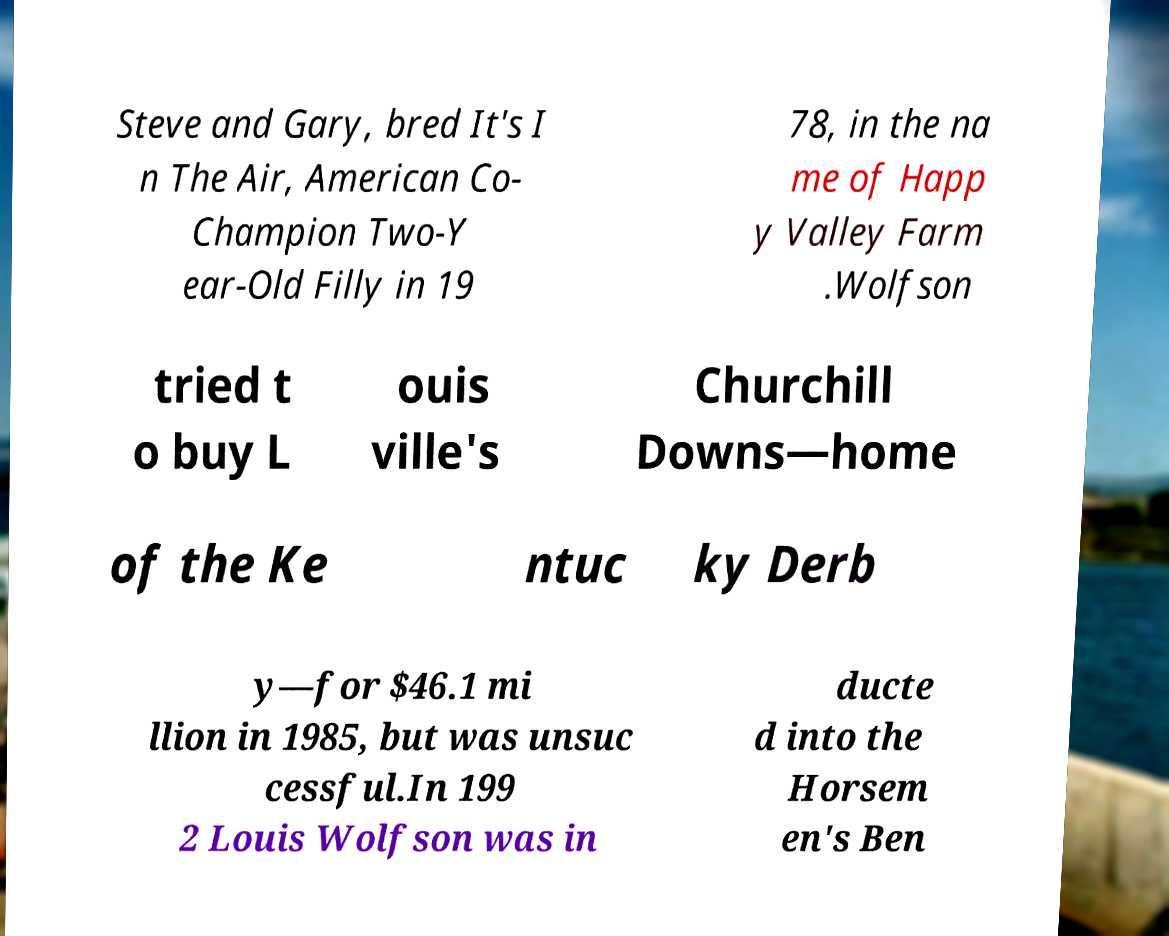Can you read and provide the text displayed in the image?This photo seems to have some interesting text. Can you extract and type it out for me? Steve and Gary, bred It's I n The Air, American Co- Champion Two-Y ear-Old Filly in 19 78, in the na me of Happ y Valley Farm .Wolfson tried t o buy L ouis ville's Churchill Downs—home of the Ke ntuc ky Derb y—for $46.1 mi llion in 1985, but was unsuc cessful.In 199 2 Louis Wolfson was in ducte d into the Horsem en's Ben 